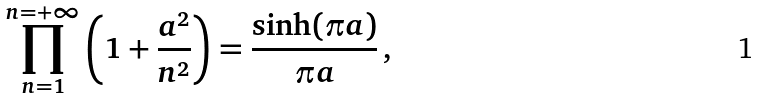<formula> <loc_0><loc_0><loc_500><loc_500>\prod _ { n = 1 } ^ { n = + \infty } \left ( 1 + \frac { a ^ { 2 } } { n ^ { 2 } } \right ) = \frac { \sinh ( \pi a ) } { \pi a } \, ,</formula> 